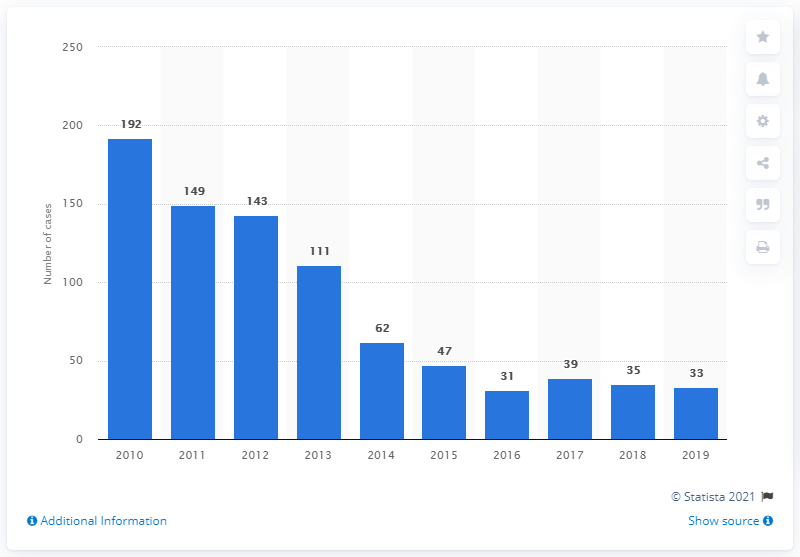Can you explain the significance of the fluctuations in malaria case numbers between 2010 and 2012? The fluctuations between 2010 and 2012 indicated on the graph could be due to a variety of factors including changes in local and regional malaria transmission patterns, the implementation of control measures, and the accuracy of reporting systems during that period. 